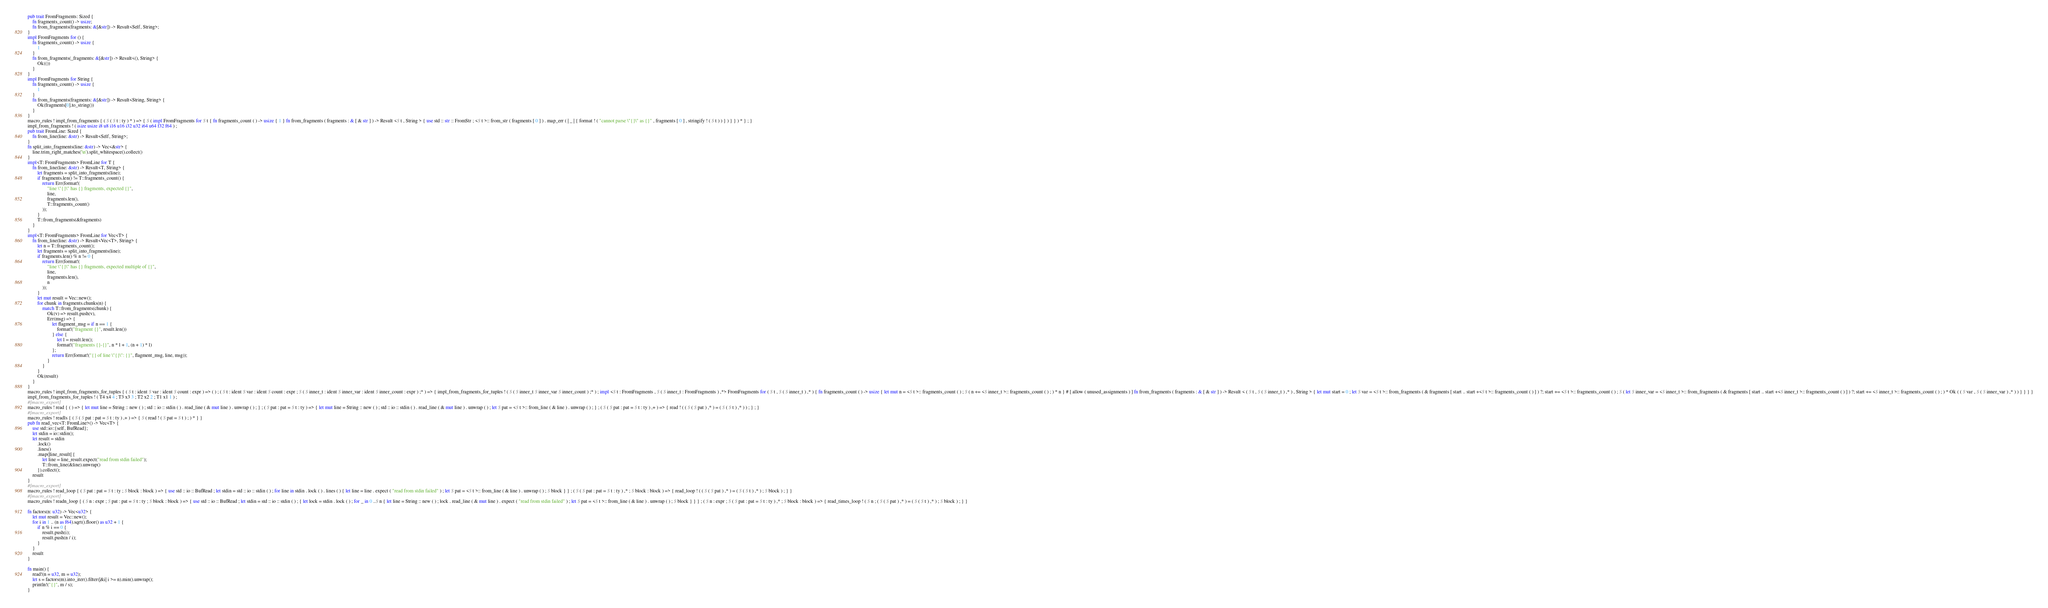Convert code to text. <code><loc_0><loc_0><loc_500><loc_500><_Rust_>pub trait FromFragments: Sized {
    fn fragments_count() -> usize;
    fn from_fragments(fragments: &[&str]) -> Result<Self, String>;
}
impl FromFragments for () {
    fn fragments_count() -> usize {
        1
    }
    fn from_fragments(_fragments: &[&str]) -> Result<(), String> {
        Ok(())
    }
}
impl FromFragments for String {
    fn fragments_count() -> usize {
        1
    }
    fn from_fragments(fragments: &[&str]) -> Result<String, String> {
        Ok(fragments[0].to_string())
    }
}
macro_rules ! impl_from_fragments { ( $ ( $ t : ty ) * ) => { $ ( impl FromFragments for $ t { fn fragments_count ( ) -> usize { 1 } fn from_fragments ( fragments : & [ & str ] ) -> Result <$ t , String > { use std :: str :: FromStr ; <$ t >:: from_str ( fragments [ 0 ] ) . map_err ( | _ | { format ! ( "cannot parse \"{}\" as {}" , fragments [ 0 ] , stringify ! ( $ t ) ) } ) } } ) * } ; }
impl_from_fragments ! ( isize usize i8 u8 i16 u16 i32 u32 i64 u64 f32 f64 ) ;
pub trait FromLine: Sized {
    fn from_line(line: &str) -> Result<Self, String>;
}
fn split_into_fragments(line: &str) -> Vec<&str> {
    line.trim_right_matches('\n').split_whitespace().collect()
}
impl<T: FromFragments> FromLine for T {
    fn from_line(line: &str) -> Result<T, String> {
        let fragments = split_into_fragments(line);
        if fragments.len() != T::fragments_count() {
            return Err(format!(
                "line \"{}\" has {} fragments, expected {}",
                line,
                fragments.len(),
                T::fragments_count()
            ));
        }
        T::from_fragments(&fragments)
    }
}
impl<T: FromFragments> FromLine for Vec<T> {
    fn from_line(line: &str) -> Result<Vec<T>, String> {
        let n = T::fragments_count();
        let fragments = split_into_fragments(line);
        if fragments.len() % n != 0 {
            return Err(format!(
                "line \"{}\" has {} fragments, expected multiple of {}",
                line,
                fragments.len(),
                n
            ));
        }
        let mut result = Vec::new();
        for chunk in fragments.chunks(n) {
            match T::from_fragments(chunk) {
                Ok(v) => result.push(v),
                Err(msg) => {
                    let flagment_msg = if n == 1 {
                        format!("fragment {}", result.len())
                    } else {
                        let l = result.len();
                        format!("fragments {}-{}", n * l + 1, (n + 1) * l)
                    };
                    return Err(format!("{} of line \"{}\": {}", flagment_msg, line, msg));
                }
            }
        }
        Ok(result)
    }
}
macro_rules ! impl_from_fragments_for_tuples { ( $ t : ident $ var : ident $ count : expr ) => ( ) ; ( $ t : ident $ var : ident $ count : expr ; $ ( $ inner_t : ident $ inner_var : ident $ inner_count : expr ) ;* ) => { impl_from_fragments_for_tuples ! ( $ ( $ inner_t $ inner_var $ inner_count ) ;* ) ; impl <$ t : FromFragments , $ ( $ inner_t : FromFragments ) ,*> FromFragments for ( $ t , $ ( $ inner_t ) ,* ) { fn fragments_count ( ) -> usize { let mut n = <$ t >:: fragments_count ( ) ; $ ( n += <$ inner_t >:: fragments_count ( ) ; ) * n } # [ allow ( unused_assignments ) ] fn from_fragments ( fragments : & [ & str ] ) -> Result < ( $ t , $ ( $ inner_t ) ,* ) , String > { let mut start = 0 ; let $ var = <$ t >:: from_fragments ( & fragments [ start .. start +<$ t >:: fragments_count ( ) ] ) ?; start += <$ t >:: fragments_count ( ) ; $ ( let $ inner_var = <$ inner_t >:: from_fragments ( & fragments [ start .. start +<$ inner_t >:: fragments_count ( ) ] ) ?; start += <$ inner_t >:: fragments_count ( ) ; ) * Ok ( ( $ var , $ ( $ inner_var ) ,* ) ) } } } }
impl_from_fragments_for_tuples ! ( T4 x4 4 ; T3 x3 3 ; T2 x2 2 ; T1 x1 1 ) ;
#[macro_export]
macro_rules ! read { ( ) => { let mut line = String :: new ( ) ; std :: io :: stdin ( ) . read_line ( & mut line ) . unwrap ( ) ; } ; ( $ pat : pat = $ t : ty ) => { let mut line = String :: new ( ) ; std :: io :: stdin ( ) . read_line ( & mut line ) . unwrap ( ) ; let $ pat = <$ t >:: from_line ( & line ) . unwrap ( ) ; } ; ( $ ( $ pat : pat = $ t : ty ) ,+ ) => { read ! ( ( $ ( $ pat ) ,* ) = ( $ ( $ t ) ,* ) ) ; } ; }
#[macro_export]
macro_rules ! readls { ( $ ( $ pat : pat = $ t : ty ) ,+ ) => { $ ( read ! ( $ pat = $ t ) ; ) * } }
pub fn read_vec<T: FromLine>() -> Vec<T> {
    use std::io::{self, BufRead};
    let stdin = io::stdin();
    let result = stdin
        .lock()
        .lines()
        .map(|line_result| {
            let line = line_result.expect("read from stdin failed");
            T::from_line(&line).unwrap()
        }).collect();
    result
}
#[macro_export]
macro_rules ! read_loop { ( $ pat : pat = $ t : ty ; $ block : block ) => { use std :: io :: BufRead ; let stdin = std :: io :: stdin ( ) ; for line in stdin . lock ( ) . lines ( ) { let line = line . expect ( "read from stdin failed" ) ; let $ pat = <$ t >:: from_line ( & line ) . unwrap ( ) ; $ block } } ; ( $ ( $ pat : pat = $ t : ty ) ,* ; $ block : block ) => { read_loop ! ( ( $ ( $ pat ) ,* ) = ( $ ( $ t ) ,* ) ; $ block ) ; } }
#[macro_export]
macro_rules ! readn_loop { ( $ n : expr ; $ pat : pat = $ t : ty ; $ block : block ) => { use std :: io :: BufRead ; let stdin = std :: io :: stdin ( ) ; { let lock = stdin . lock ( ) ; for _ in 0 ..$ n { let line = String :: new ( ) ; lock . read_line ( & mut line ) . expect ( "read from stdin failed" ) ; let $ pat = <$ t >:: from_line ( & line ) . unwrap ( ) ; $ block } } } ; ( $ n : expr ; $ ( $ pat : pat = $ t : ty ) ,* ; $ block : block ) => { read_times_loop ! ( $ n ; ( $ ( $ pat ) ,* ) = ( $ ( $ t ) ,* ) ; $ block ) ; } }

fn factors(n: u32) -> Vec<u32> {
    let mut result = Vec::new();
    for i in 1 .. (n as f64).sqrt().floor() as u32 + 1 {
        if n % i == 0 {
            result.push(i);
            result.push(n / i);
        }
    }
    result
}

fn main() {
    read!(n = u32, m = u32);
    let s = factors(m).into_iter().filter(|&i| i >= n).min().unwrap();
    println!("{}", m / s);
}
</code> 